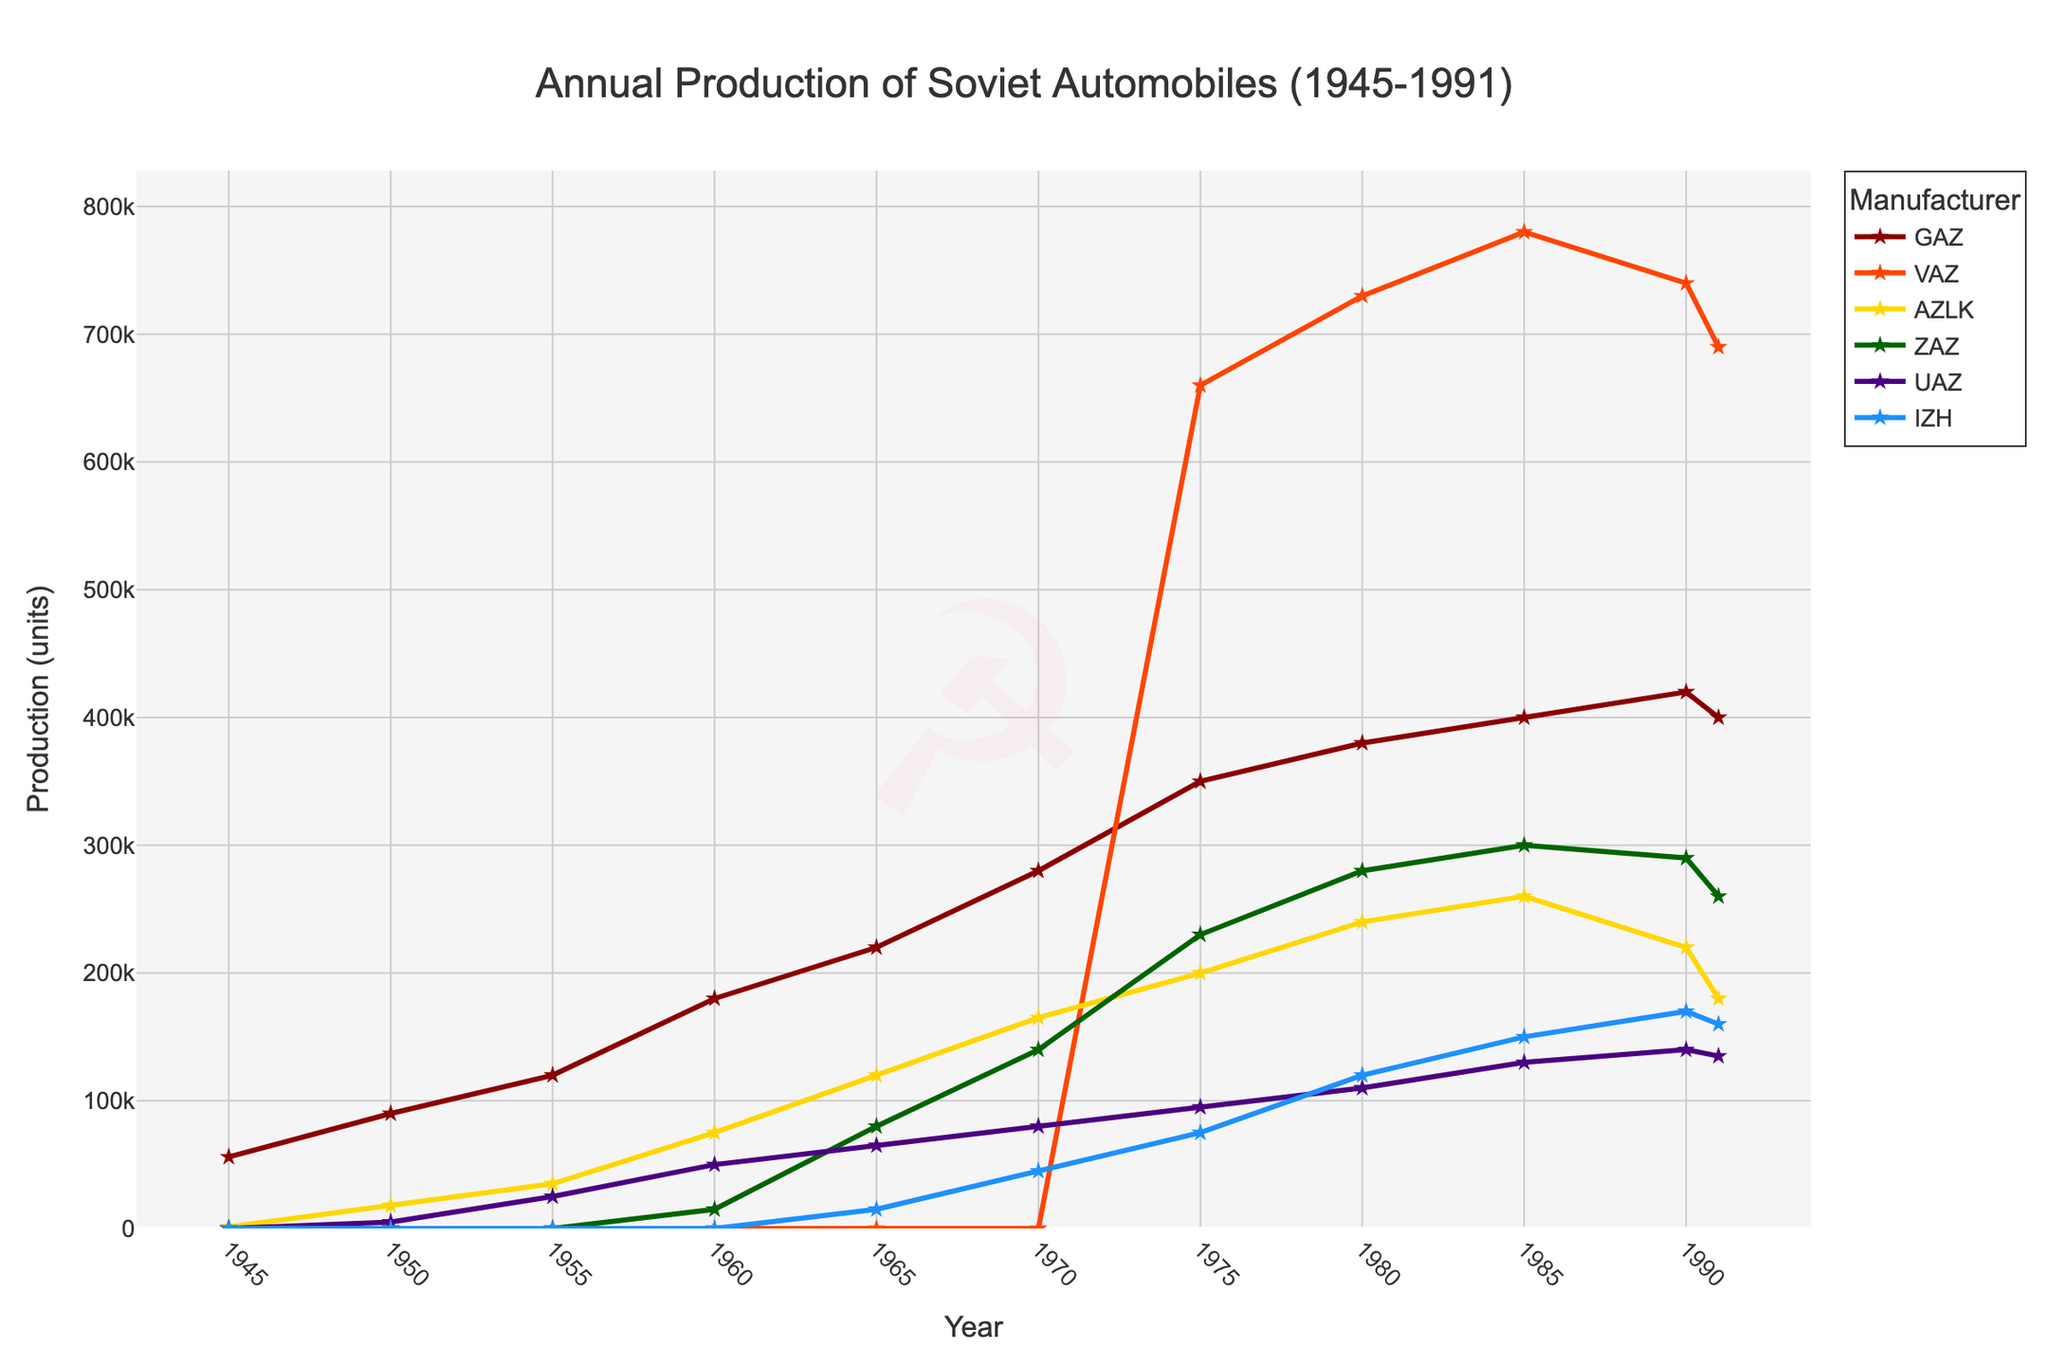Which manufacturer had the highest production in 1980? By looking at the 1980 data points on the chart, observe the peak values. VAZ shows the highest production number.
Answer: VAZ What is the total production of ZAZ between 1975 and 1991? Sum the production values for ZAZ from the years 1975 (230,000), 1980 (280,000), 1985 (300,000), 1990 (290,000), and 1991 (260,000). The total is 1,360,000 units.
Answer: 1,360,000 Who had a higher production in 1990, AZLK or UAZ? Compare the production values for AZLK (220,000) and UAZ (140,000) in 1990. AZLK's production is higher.
Answer: AZLK In which year did GAZ production surpass 300,000 units for the first time, and what was the approximate number? Identify the first year where GAZ's production crosses 300,000 units. This occurs in 1975, where the number is 350,000 units.
Answer: 1975, 350,000 How many manufacturers were producing cars in 1960? Check the number of manufacturers with non-zero production values in 1960. GAZ, AZLK, ZAZ, and UAZ were producing.
Answer: 4 Calculate the average annual production of IZH between 1965 and 1991. Find the production values for IZH for the years with available data: 1965 (15,000), 1970 (45,000), 1975 (75,000), 1980 (120,000), 1985 (150,000), 1990 (170,000), and 1991 (160,000). Compute the average: (15,000 + 45,000 + 75,000 + 120,000 + 150,000 + 170,000 + 160,000) / 7 = 105,714 (rounded to nearest unit).
Answer: 105,714 What is the color of the line representing VAZ production? Look at the color coding of the lines on the chart. VAZ is represented in orange.
Answer: orange By how much did the production of UAZ increase from 1950 to 1980? Subtract UAZ's production in 1950 (5,000) from its production in 1980 (110,000). 110,000 - 5,000 = 105,000.
Answer: 105,000 Which manufacturer had the steepest rise in production between 1970 and 1975? Compare the changes in production for each manufacturer between 1970 and 1975. VAZ's production increased from 0 to 660,000, which is the largest rise.
Answer: VAZ How did AZLK's production in 1985 compare to 1991? Check the production values for AZLK in 1985 (260,000) and 1991 (180,000). Notice the decrease by subtracting the two values: 260,000 - 180,000 = 80,000 units.
Answer: Decreased by 80,000 units 